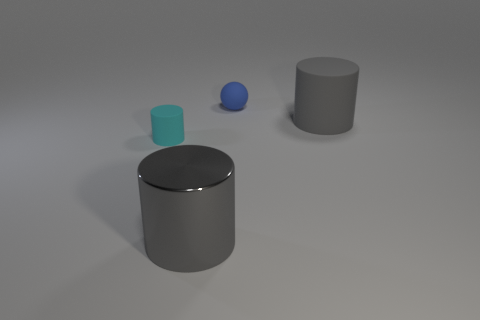Subtract all red cubes. How many gray cylinders are left? 2 Subtract all big gray cylinders. How many cylinders are left? 1 Add 2 tiny rubber cylinders. How many objects exist? 6 Subtract all balls. How many objects are left? 3 Subtract 1 blue balls. How many objects are left? 3 Subtract all large green shiny balls. Subtract all matte objects. How many objects are left? 1 Add 1 tiny cyan cylinders. How many tiny cyan cylinders are left? 2 Add 2 rubber things. How many rubber things exist? 5 